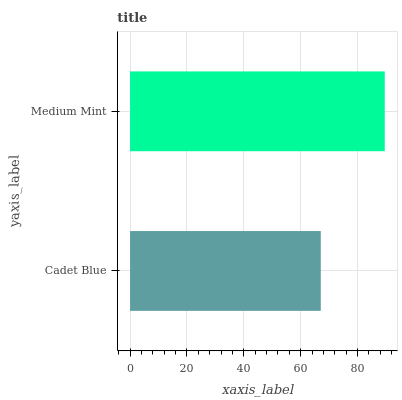Is Cadet Blue the minimum?
Answer yes or no. Yes. Is Medium Mint the maximum?
Answer yes or no. Yes. Is Medium Mint the minimum?
Answer yes or no. No. Is Medium Mint greater than Cadet Blue?
Answer yes or no. Yes. Is Cadet Blue less than Medium Mint?
Answer yes or no. Yes. Is Cadet Blue greater than Medium Mint?
Answer yes or no. No. Is Medium Mint less than Cadet Blue?
Answer yes or no. No. Is Medium Mint the high median?
Answer yes or no. Yes. Is Cadet Blue the low median?
Answer yes or no. Yes. Is Cadet Blue the high median?
Answer yes or no. No. Is Medium Mint the low median?
Answer yes or no. No. 